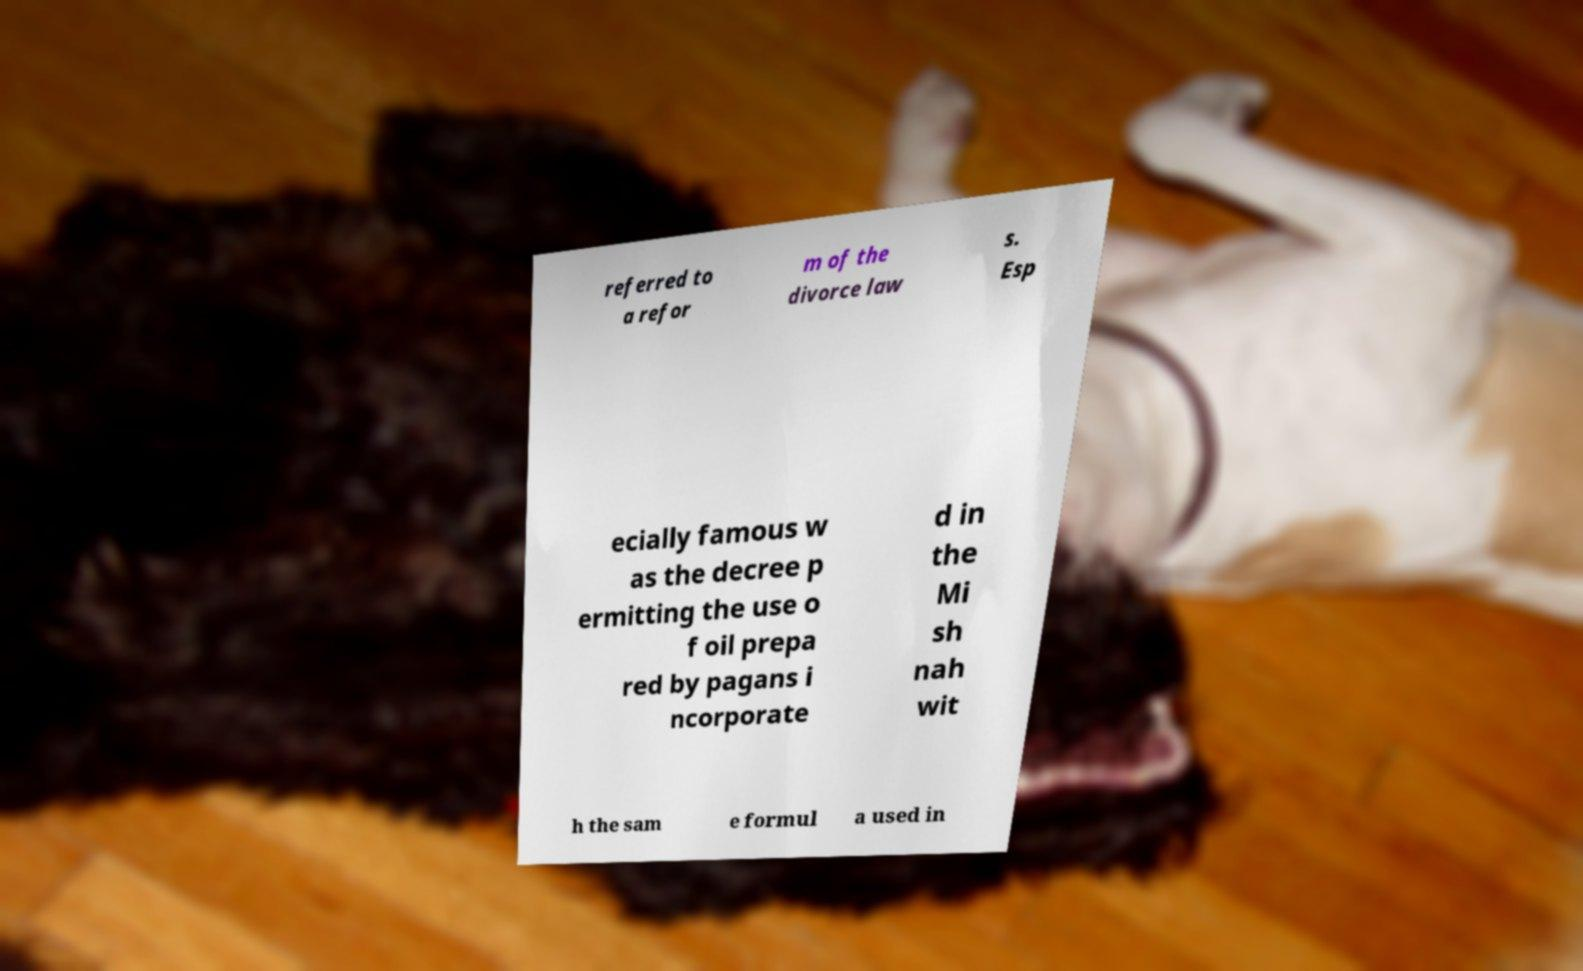What messages or text are displayed in this image? I need them in a readable, typed format. referred to a refor m of the divorce law s. Esp ecially famous w as the decree p ermitting the use o f oil prepa red by pagans i ncorporate d in the Mi sh nah wit h the sam e formul a used in 